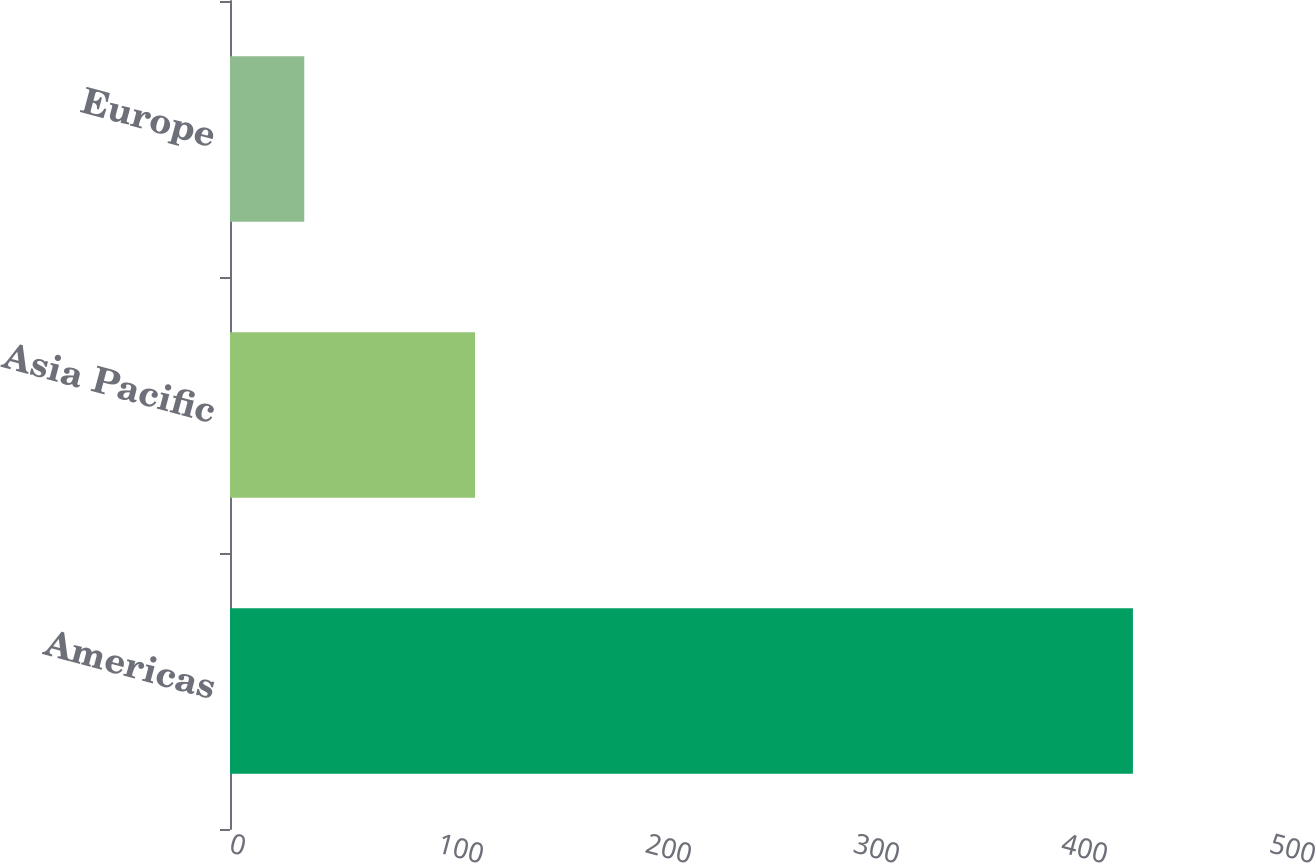<chart> <loc_0><loc_0><loc_500><loc_500><bar_chart><fcel>Americas<fcel>Asia Pacific<fcel>Europe<nl><fcel>434.1<fcel>117.8<fcel>35.7<nl></chart> 